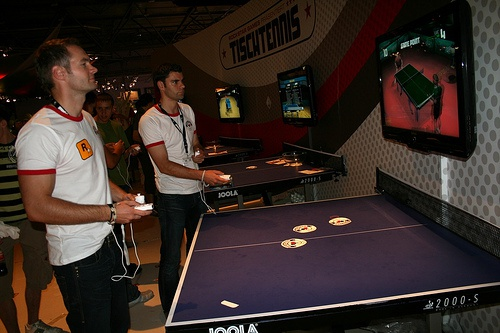Describe the objects in this image and their specific colors. I can see people in black, darkgray, maroon, and brown tones, tv in black, maroon, brown, and gray tones, people in black, darkgray, maroon, and brown tones, people in black, darkgreen, and gray tones, and tv in black, olive, darkblue, and teal tones in this image. 